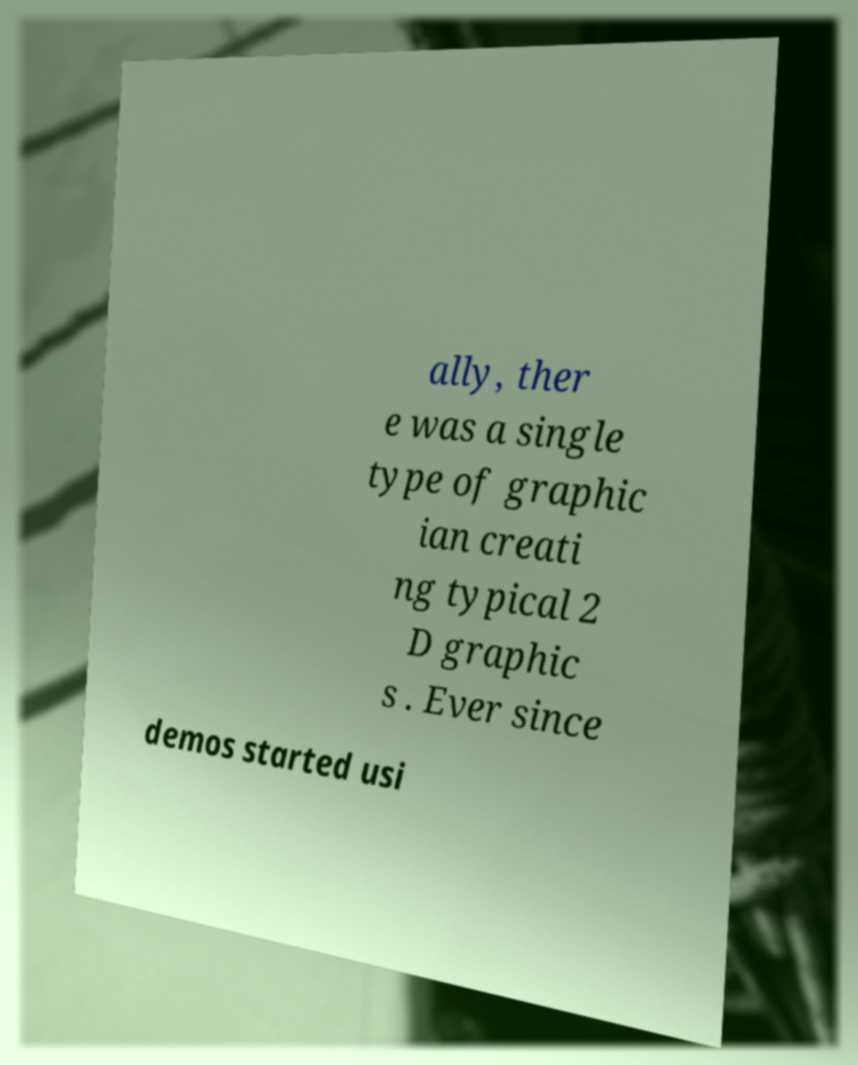There's text embedded in this image that I need extracted. Can you transcribe it verbatim? ally, ther e was a single type of graphic ian creati ng typical 2 D graphic s . Ever since demos started usi 